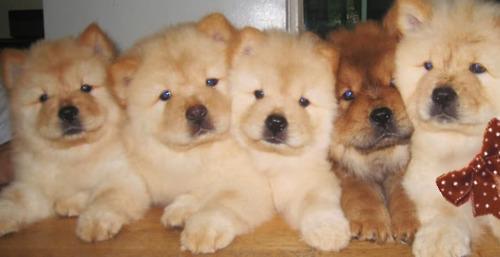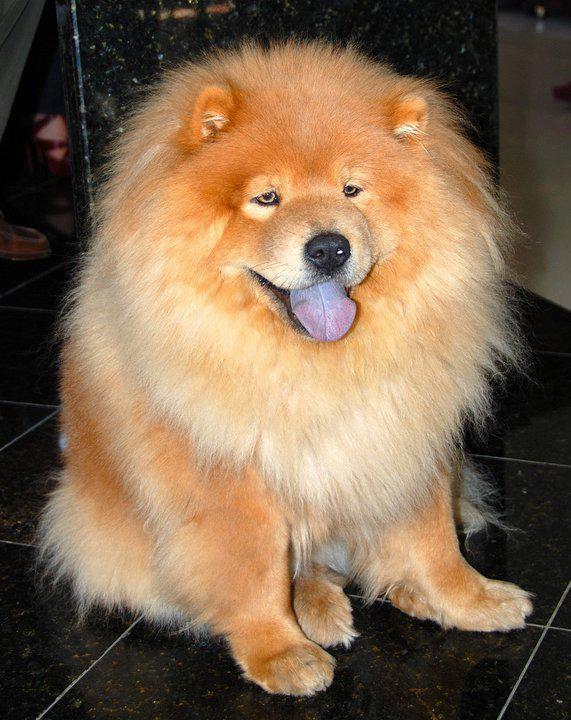The first image is the image on the left, the second image is the image on the right. Considering the images on both sides, is "There are 4 chows in the image pair" valid? Answer yes or no. No. The first image is the image on the left, the second image is the image on the right. Evaluate the accuracy of this statement regarding the images: "The right image contains exactly two chow dogs.". Is it true? Answer yes or no. No. 